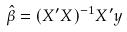Convert formula to latex. <formula><loc_0><loc_0><loc_500><loc_500>\hat { \beta } = ( X ^ { \prime } X ) ^ { - 1 } X ^ { \prime } y</formula> 